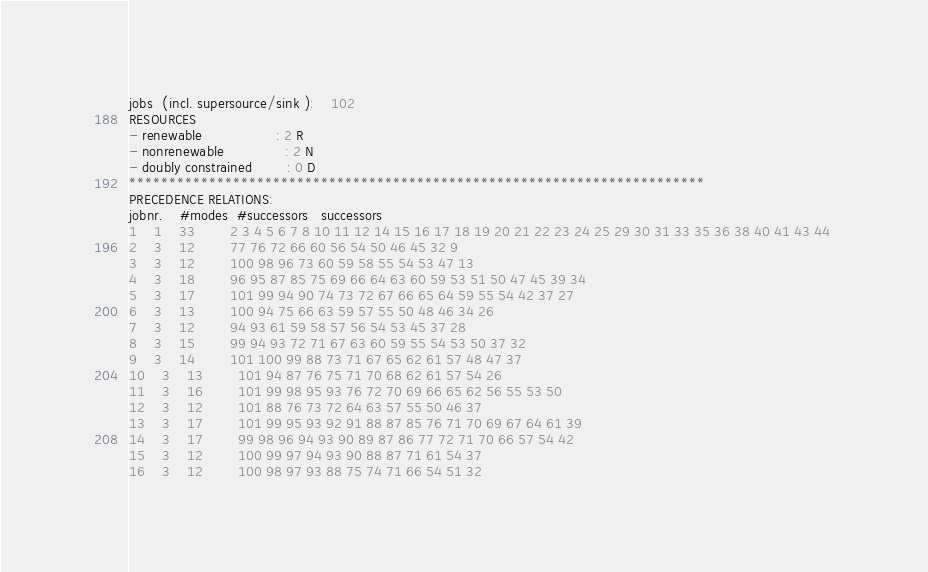Convert code to text. <code><loc_0><loc_0><loc_500><loc_500><_ObjectiveC_>jobs  (incl. supersource/sink ):	102
RESOURCES
- renewable                 : 2 R
- nonrenewable              : 2 N
- doubly constrained        : 0 D
************************************************************************
PRECEDENCE RELATIONS:
jobnr.    #modes  #successors   successors
1	1	33		2 3 4 5 6 7 8 10 11 12 14 15 16 17 18 19 20 21 22 23 24 25 29 30 31 33 35 36 38 40 41 43 44 
2	3	12		77 76 72 66 60 56 54 50 46 45 32 9 
3	3	12		100 98 96 73 60 59 58 55 54 53 47 13 
4	3	18		96 95 87 85 75 69 66 64 63 60 59 53 51 50 47 45 39 34 
5	3	17		101 99 94 90 74 73 72 67 66 65 64 59 55 54 42 37 27 
6	3	13		100 94 75 66 63 59 57 55 50 48 46 34 26 
7	3	12		94 93 61 59 58 57 56 54 53 45 37 28 
8	3	15		99 94 93 72 71 67 63 60 59 55 54 53 50 37 32 
9	3	14		101 100 99 88 73 71 67 65 62 61 57 48 47 37 
10	3	13		101 94 87 76 75 71 70 68 62 61 57 54 26 
11	3	16		101 99 98 95 93 76 72 70 69 66 65 62 56 55 53 50 
12	3	12		101 88 76 73 72 64 63 57 55 50 46 37 
13	3	17		101 99 95 93 92 91 88 87 85 76 71 70 69 67 64 61 39 
14	3	17		99 98 96 94 93 90 89 87 86 77 72 71 70 66 57 54 42 
15	3	12		100 99 97 94 93 90 88 87 71 61 54 37 
16	3	12		100 98 97 93 88 75 74 71 66 54 51 32 </code> 